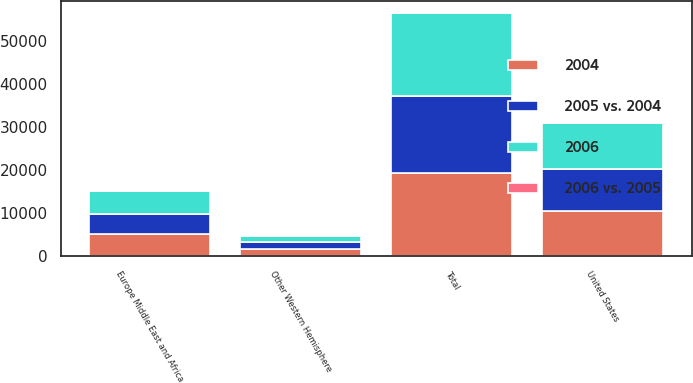Convert chart. <chart><loc_0><loc_0><loc_500><loc_500><stacked_bar_chart><ecel><fcel>United States<fcel>Europe Middle East and Africa<fcel>Other Western Hemisphere<fcel>Total<nl><fcel>2005 vs. 2004<fcel>9729<fcel>4544<fcel>1615<fcel>17914<nl><fcel>2004<fcel>10461<fcel>5136<fcel>1592<fcel>19207<nl><fcel>2006<fcel>10613<fcel>5470<fcel>1425<fcel>19380<nl><fcel>2006 vs. 2005<fcel>7<fcel>12<fcel>1<fcel>7<nl></chart> 